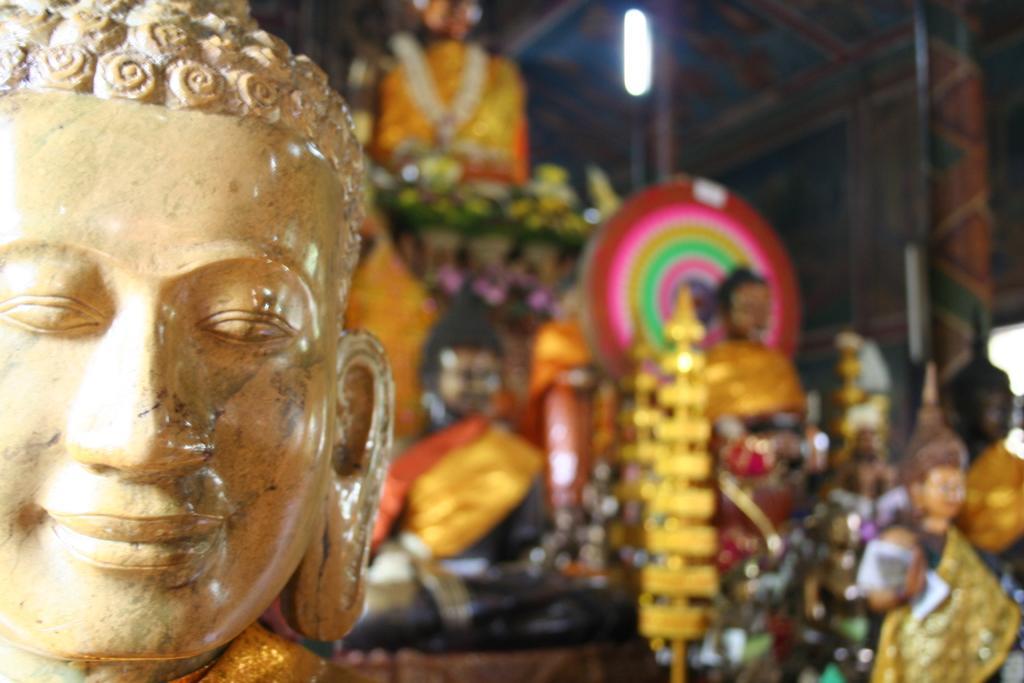Can you describe this image briefly? In this picture there are statues on the right and left side of the image. 